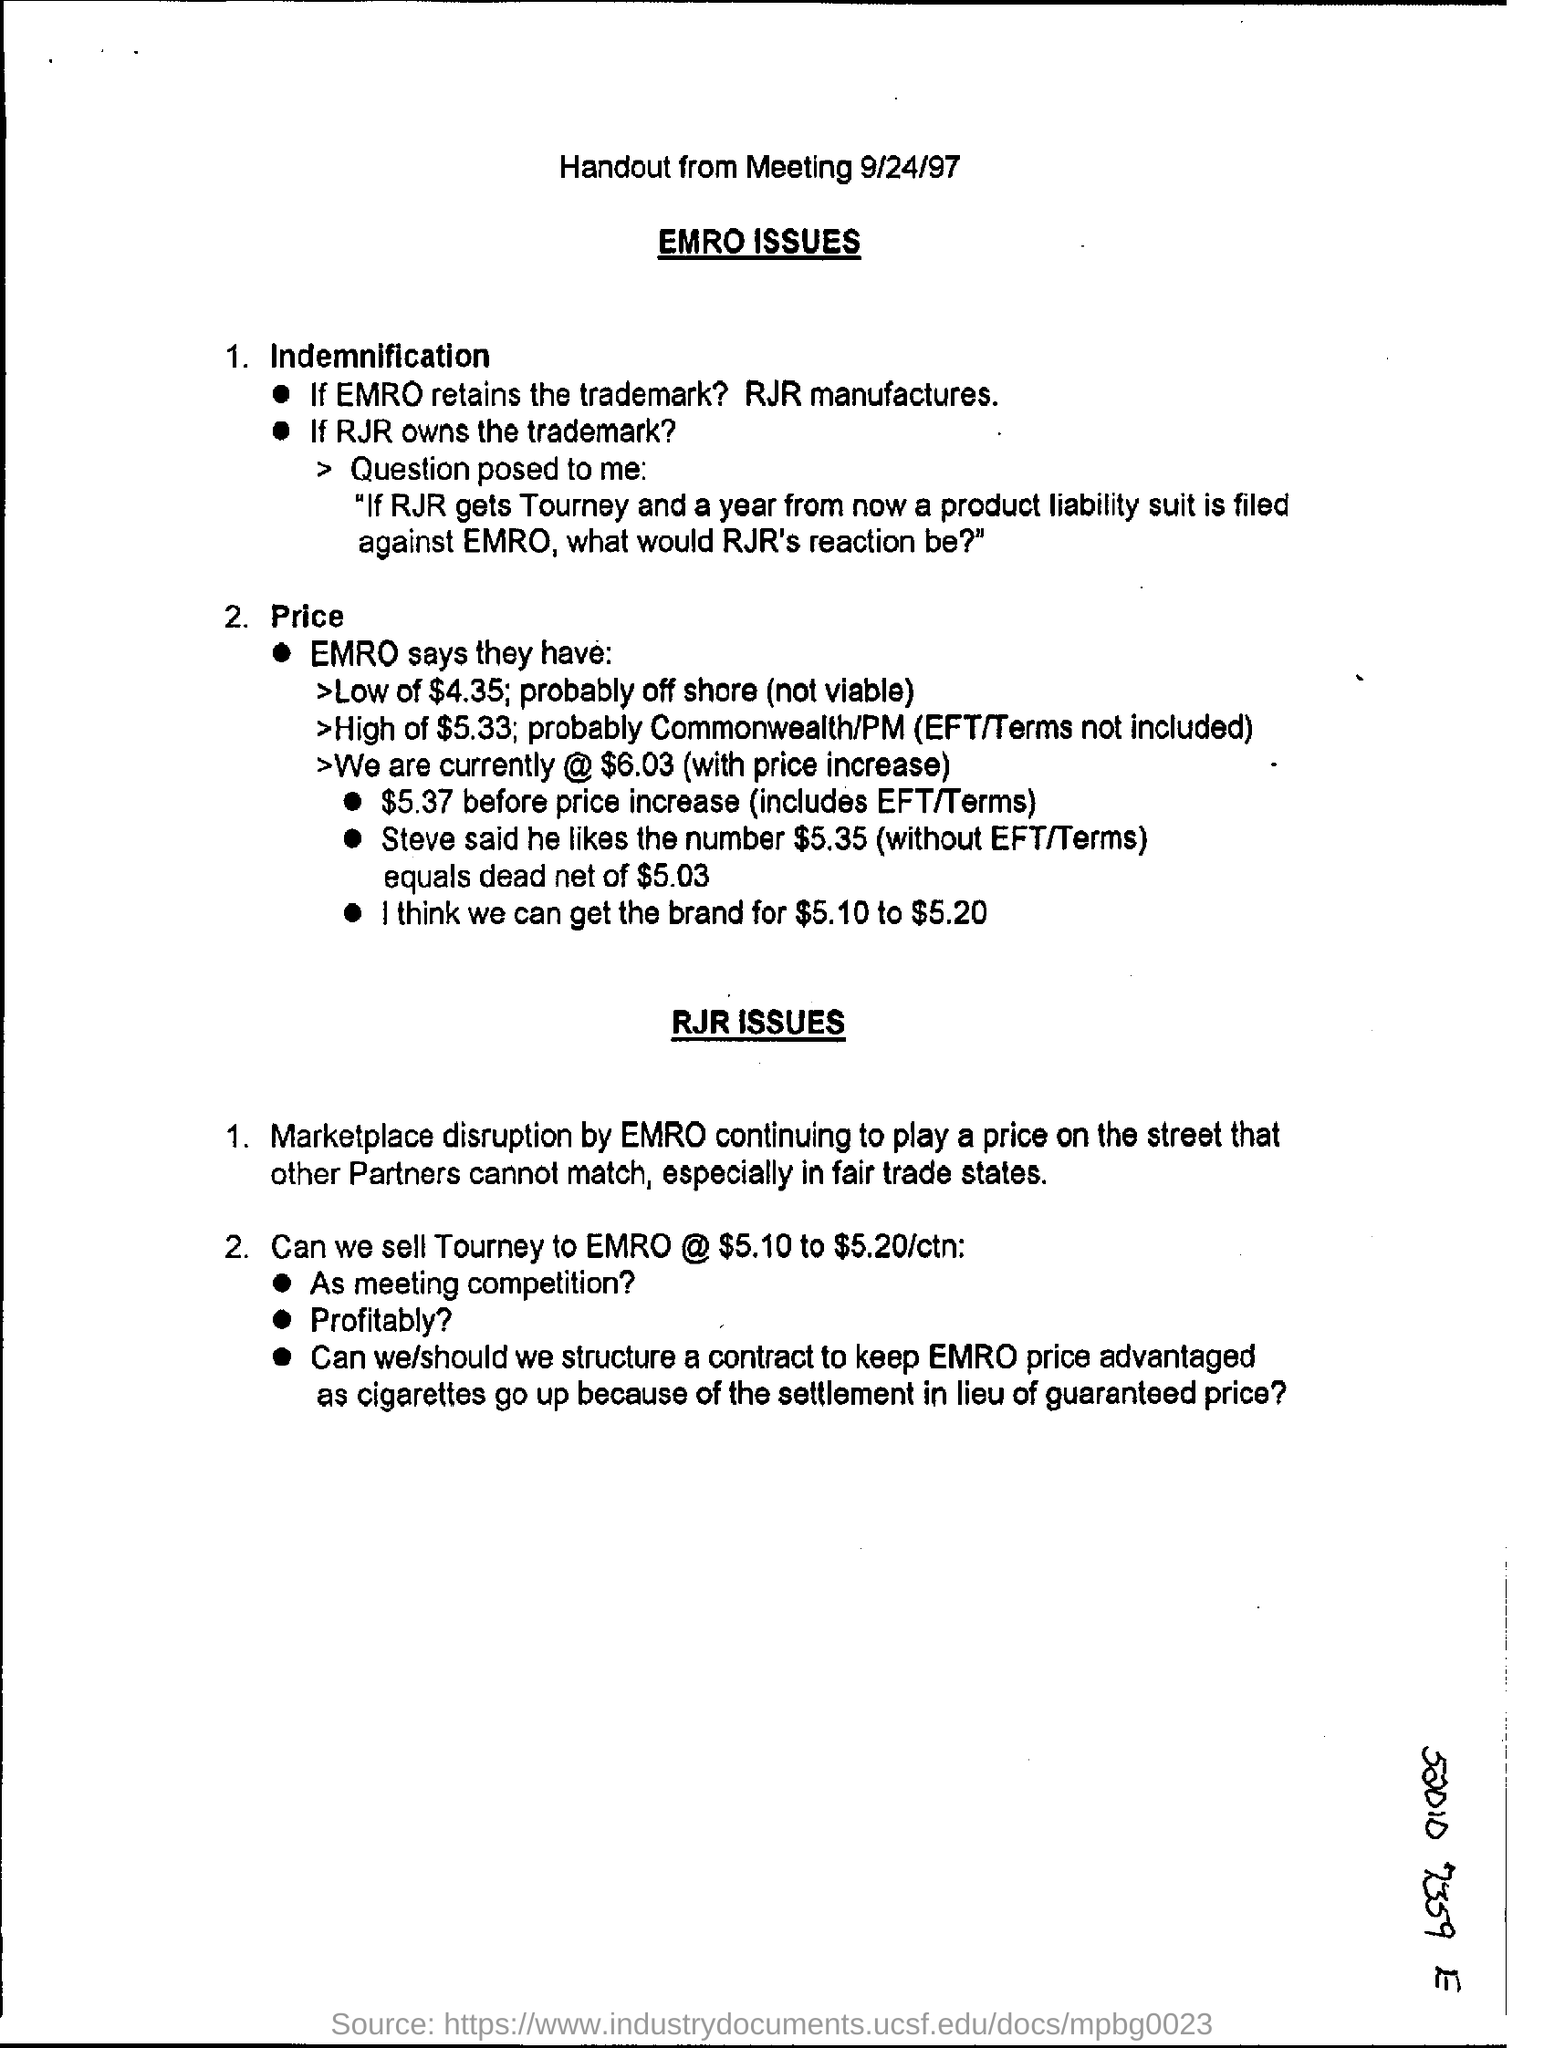Give some essential details in this illustration. The current date displayed at the top of the page is September 24th, 1997. 